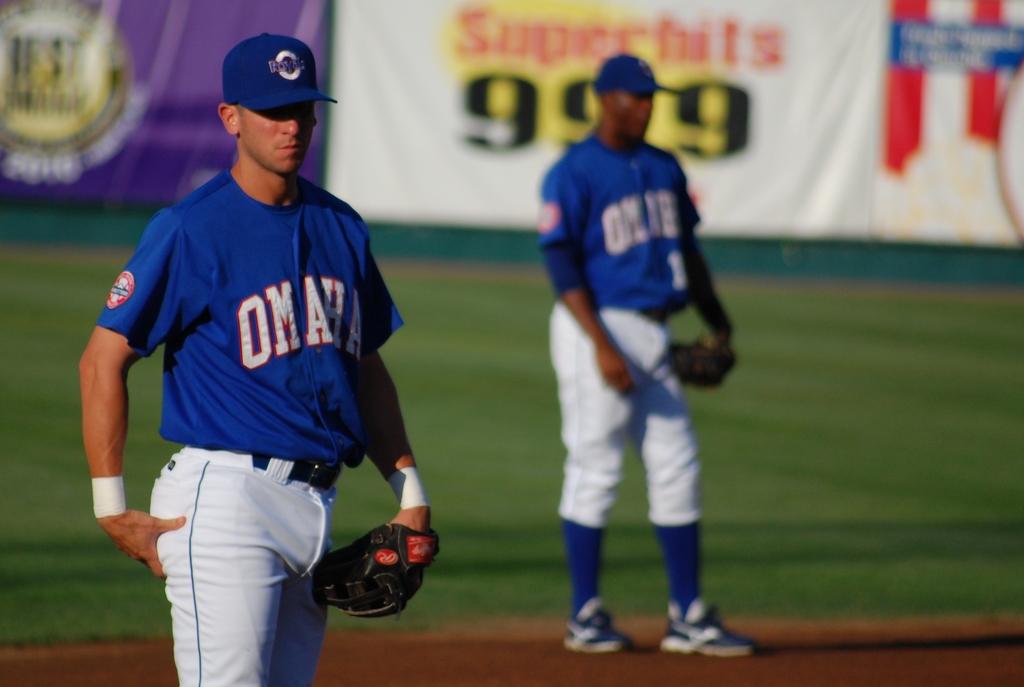Which city does this team play for?
Provide a succinct answer. Omaha. What three numbers is in the background?
Offer a terse response. 999. 